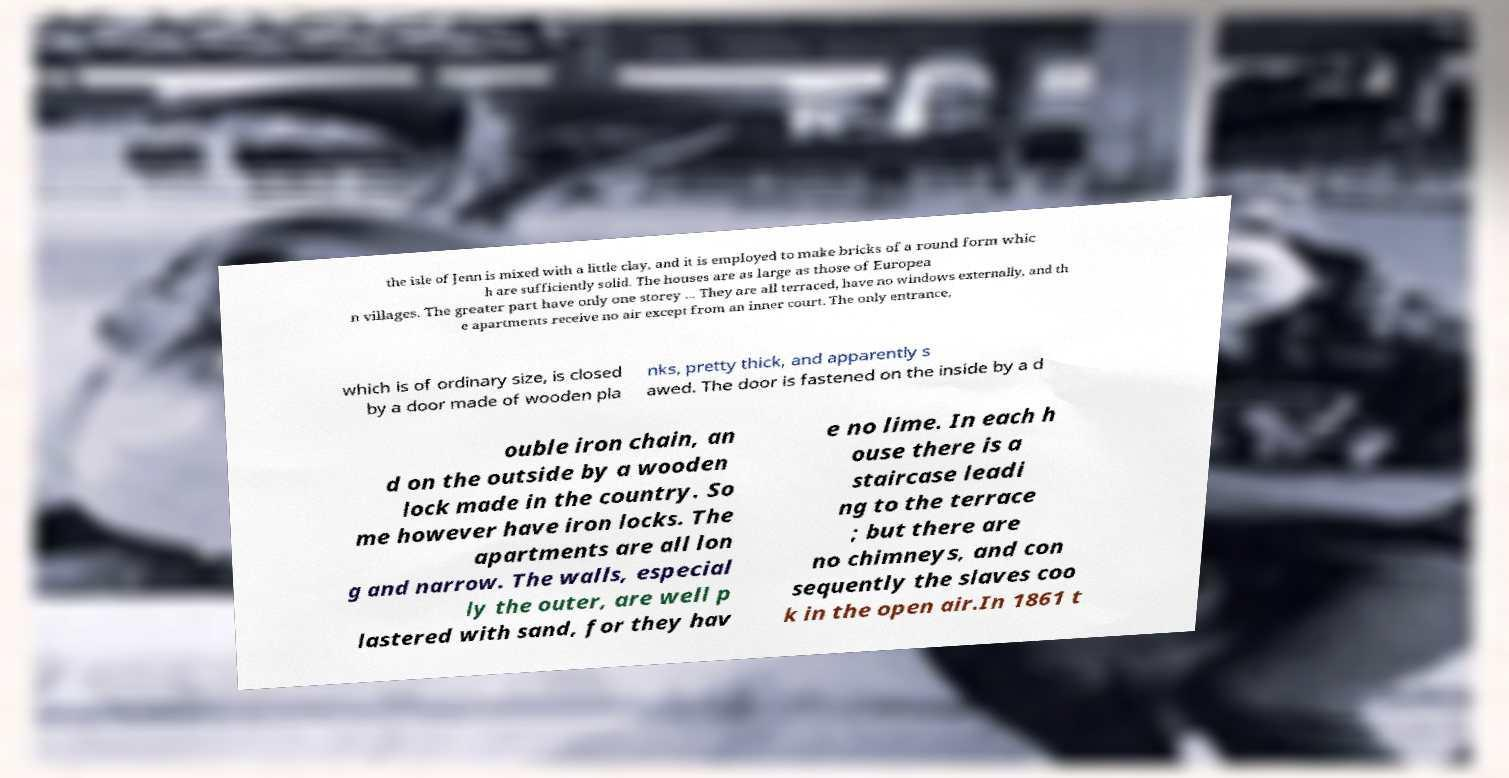For documentation purposes, I need the text within this image transcribed. Could you provide that? the isle of Jenn is mixed with a little clay, and it is employed to make bricks of a round form whic h are sufficiently solid. The houses are as large as those of Europea n villages. The greater part have only one storey ... They are all terraced, have no windows externally, and th e apartments receive no air except from an inner court. The only entrance, which is of ordinary size, is closed by a door made of wooden pla nks, pretty thick, and apparently s awed. The door is fastened on the inside by a d ouble iron chain, an d on the outside by a wooden lock made in the country. So me however have iron locks. The apartments are all lon g and narrow. The walls, especial ly the outer, are well p lastered with sand, for they hav e no lime. In each h ouse there is a staircase leadi ng to the terrace ; but there are no chimneys, and con sequently the slaves coo k in the open air.In 1861 t 